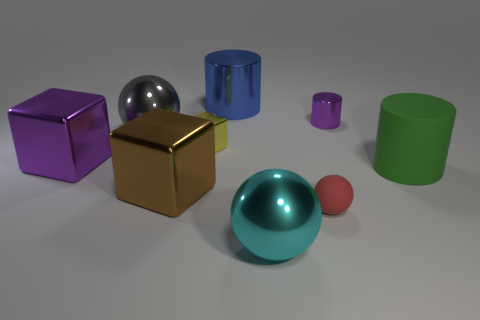Are there fewer tiny purple objects that are in front of the tiny rubber object than metal cylinders to the left of the cyan metallic object?
Your answer should be compact. Yes. What is the color of the other large object that is the same shape as the large cyan shiny thing?
Provide a short and direct response. Gray. There is a purple metallic thing that is left of the red thing; does it have the same size as the cyan shiny thing?
Give a very brief answer. Yes. Is the number of large green things that are behind the big green rubber cylinder less than the number of large blue rubber blocks?
Your answer should be very brief. No. How big is the brown thing that is behind the big metallic sphere that is on the right side of the brown metal block?
Provide a succinct answer. Large. Is the number of cyan metal balls less than the number of tiny brown shiny balls?
Give a very brief answer. No. The sphere that is both behind the cyan sphere and right of the gray thing is made of what material?
Ensure brevity in your answer.  Rubber. There is a shiny cylinder in front of the blue shiny object; are there any small rubber balls that are behind it?
Provide a succinct answer. No. How many things are tiny red balls or tiny yellow cylinders?
Keep it short and to the point. 1. The small thing that is both to the right of the blue metal cylinder and to the left of the small shiny cylinder has what shape?
Your answer should be compact. Sphere. 